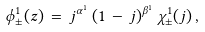<formula> <loc_0><loc_0><loc_500><loc_500>\phi _ { \pm } ^ { 1 } ( z ) \, = \, j ^ { \alpha ^ { 1 } } \, ( 1 \, - \, j ) ^ { \beta ^ { 1 } } \, \chi _ { \pm } ^ { 1 } ( j ) \, ,</formula> 